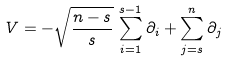Convert formula to latex. <formula><loc_0><loc_0><loc_500><loc_500>V = - \sqrt { \frac { n - s } { s } } \, \sum _ { i = 1 } ^ { s - 1 } \partial _ { i } + \sum _ { j = s } ^ { n } \partial _ { j }</formula> 